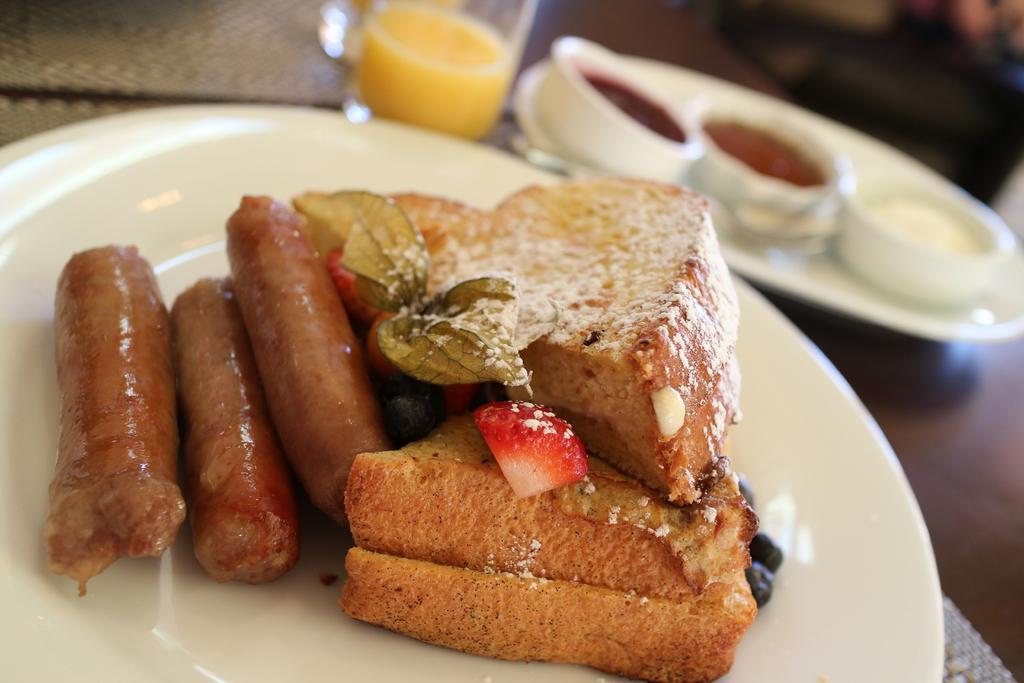In one or two sentences, can you explain what this image depicts? In this image, there is a plate contains some food. There is an another plate in the top right of the image contains bowls. There is a glass at the top of the image. 